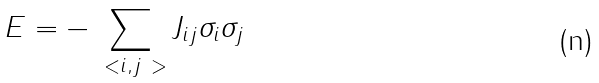Convert formula to latex. <formula><loc_0><loc_0><loc_500><loc_500>E = - \sum _ { \ < i , j \ > } J _ { i j } \sigma _ { i } \sigma _ { j }</formula> 